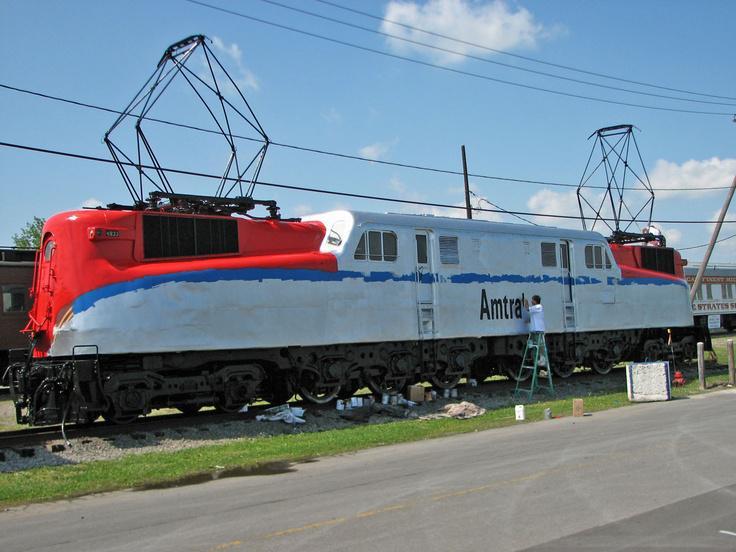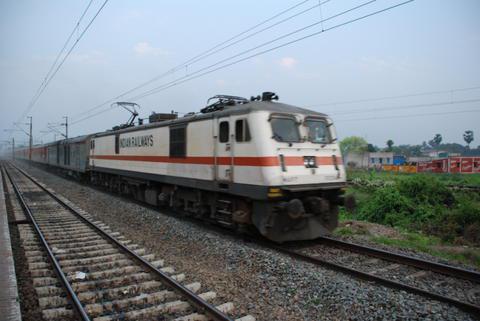The first image is the image on the left, the second image is the image on the right. Considering the images on both sides, is "Right image shows a white train with a red stripe only and an angled front." valid? Answer yes or no. Yes. The first image is the image on the left, the second image is the image on the right. Analyze the images presented: Is the assertion "One train is white with a single red horizontal stripe around the body." valid? Answer yes or no. Yes. 